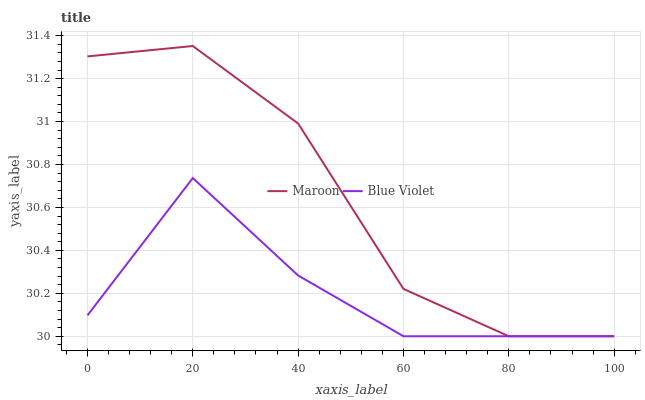Does Maroon have the minimum area under the curve?
Answer yes or no. No. Is Maroon the smoothest?
Answer yes or no. No. 